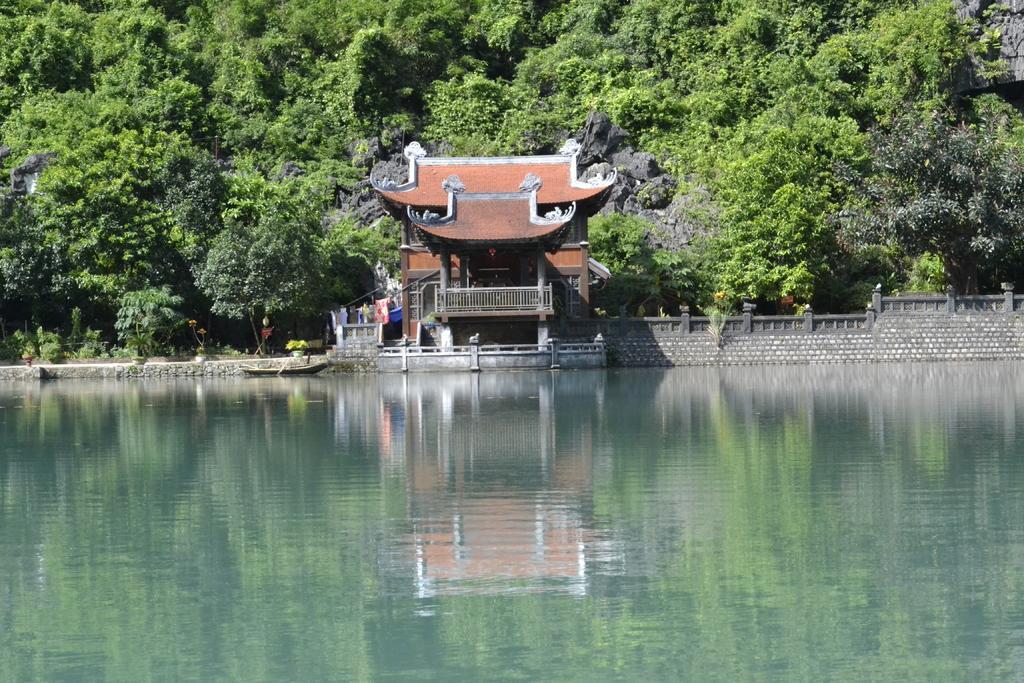How would you summarize this image in a sentence or two? In this picture we can see water, boat, wall, house with fence, pillars and a beautiful roof top. In the background we can see tree, hills. 